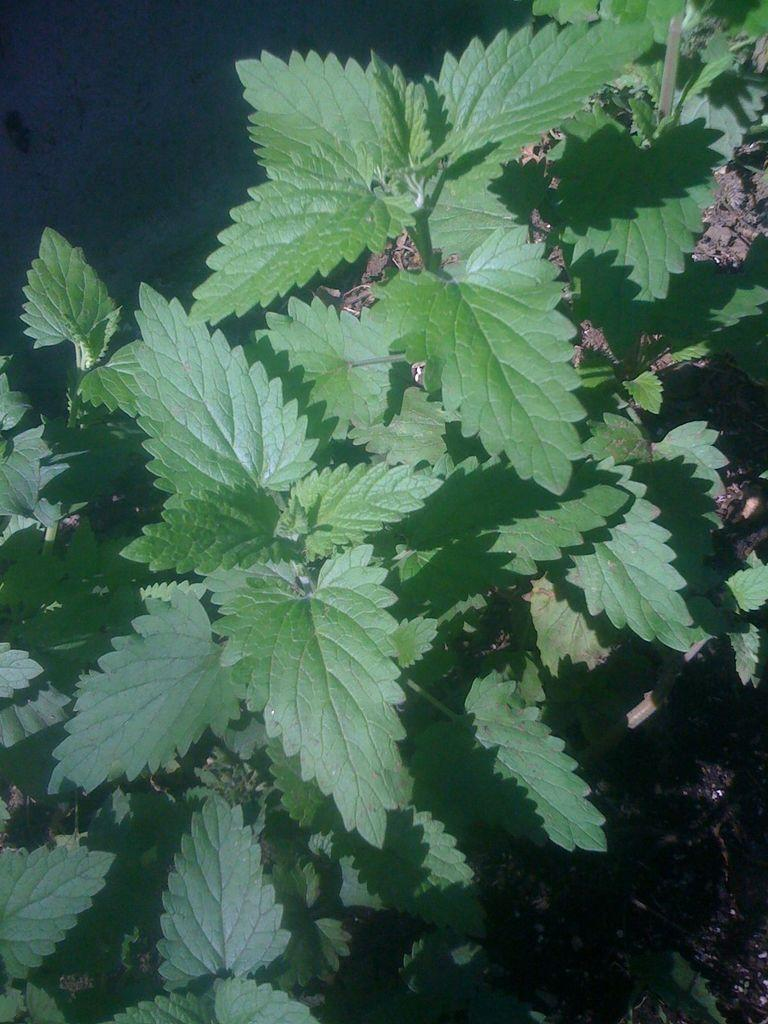What color are the leaves in the image? The leaves in the image are green. Are there any tomatoes hanging from the leaves in the image? There is no mention of tomatoes in the provided facts, and therefore we cannot determine if they are present in the image. 